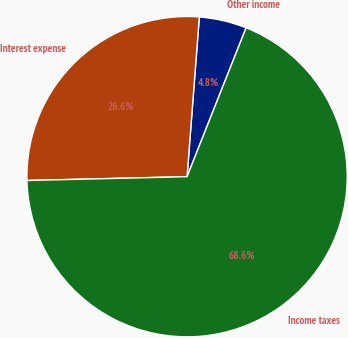Convert chart. <chart><loc_0><loc_0><loc_500><loc_500><pie_chart><fcel>Other income<fcel>Interest expense<fcel>Income taxes<nl><fcel>4.79%<fcel>26.6%<fcel>68.61%<nl></chart> 